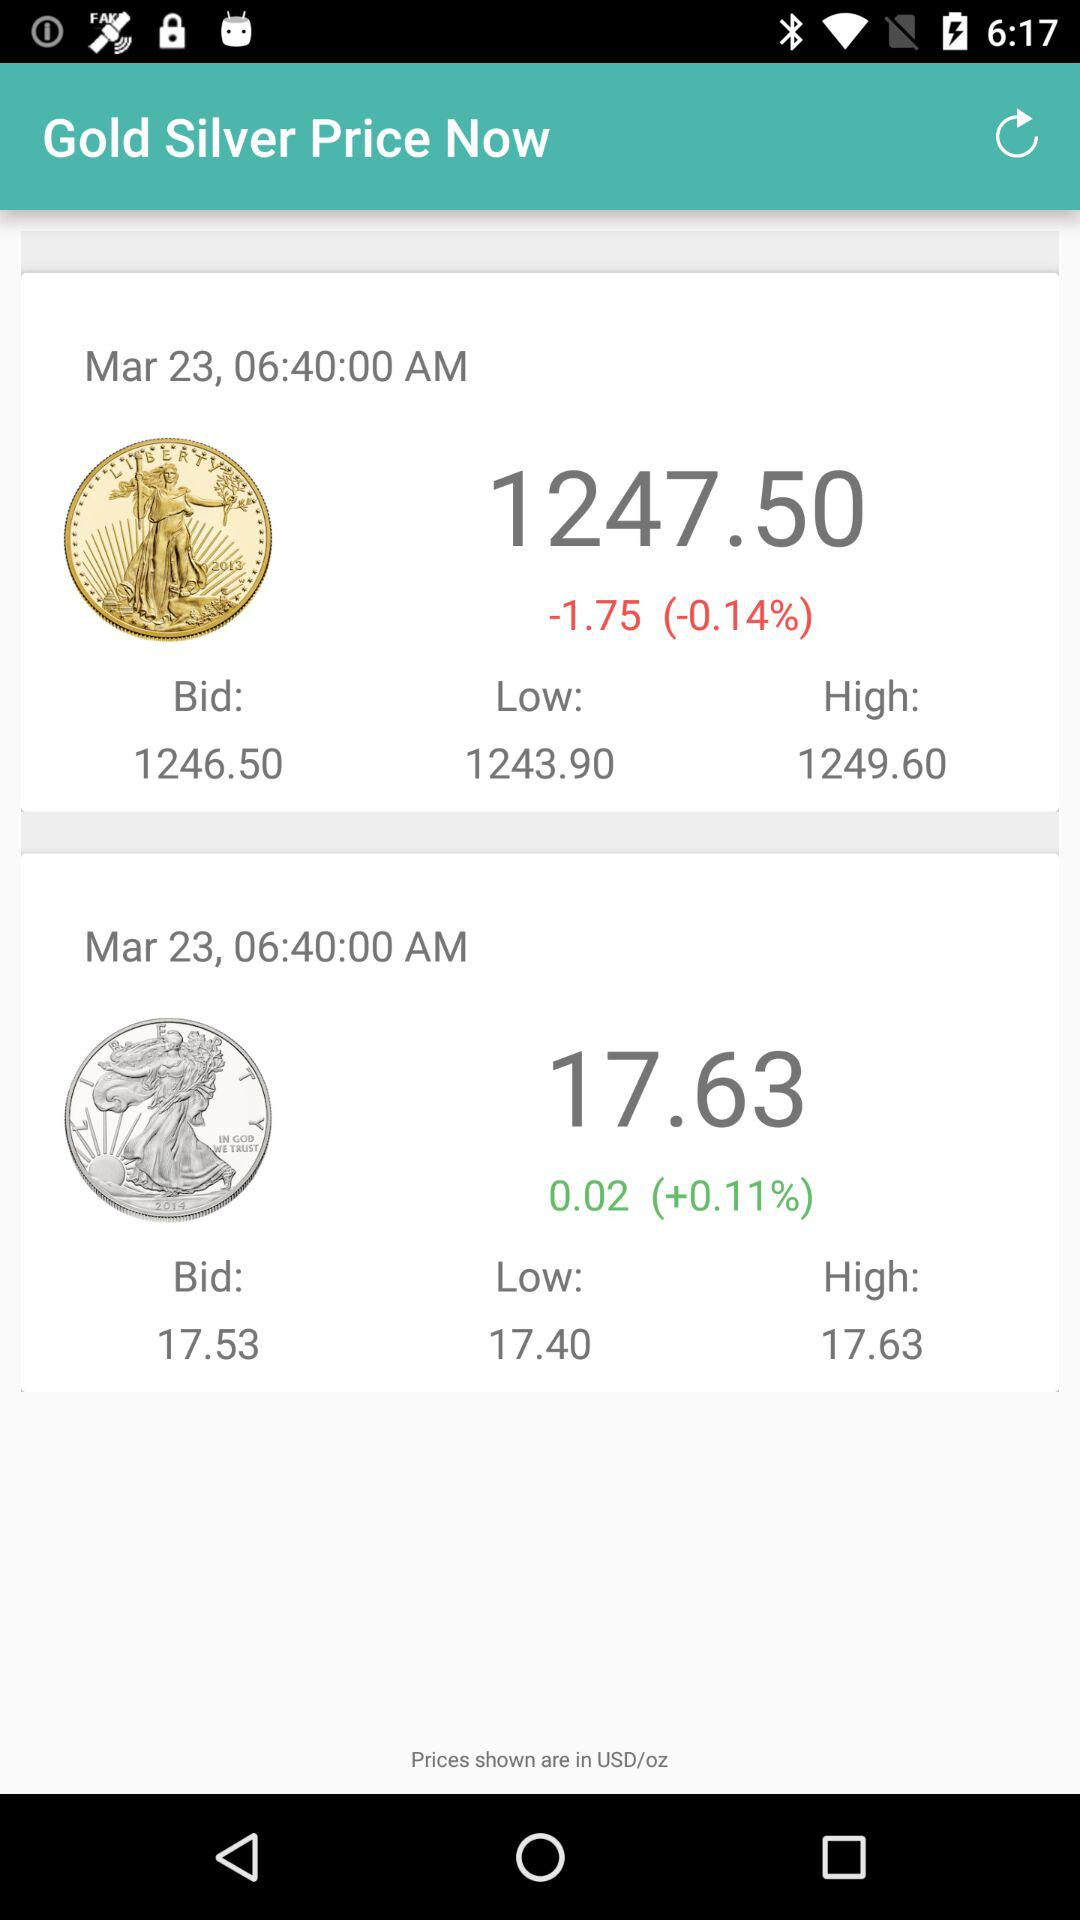What is the difference between the lowest silver price and the highest silver price?
Answer the question using a single word or phrase. 0.23 